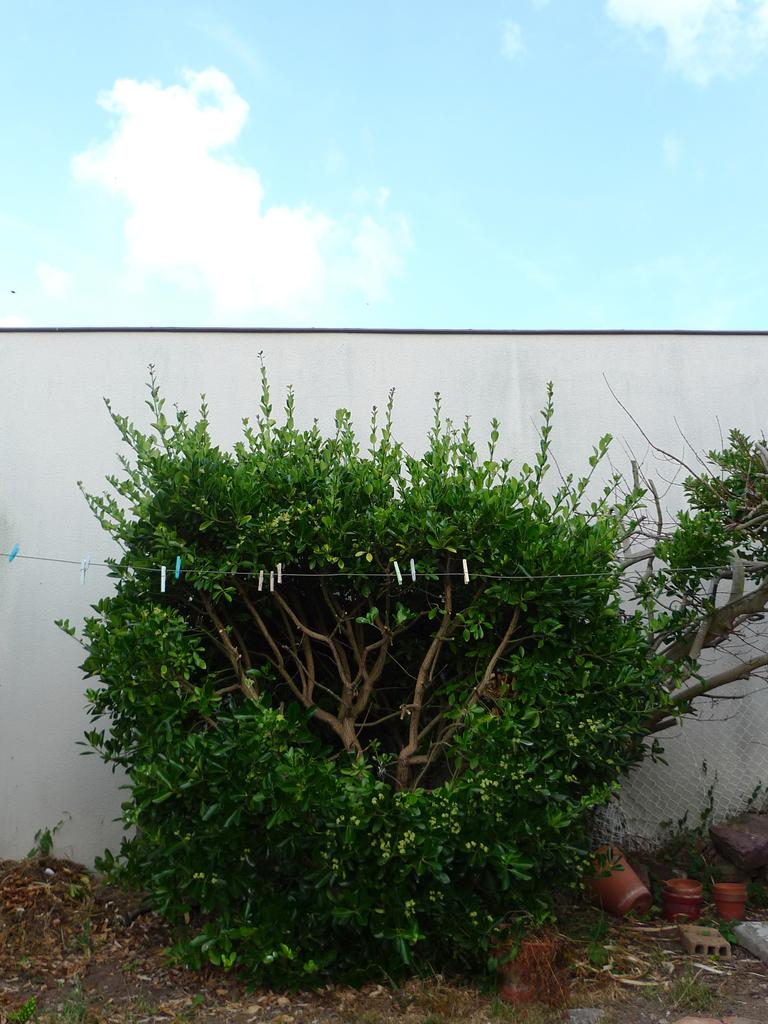What type of plant can be seen in the image? There is a tree in the image. What is attached to the wire in the image? There are clips on a wire in the image. What objects are on the ground in the image? There are flower pots on the ground in the image. What is the background of the image? The sky with clouds is visible in the background of the image. What type of structure is present in the image? There is a wall in the image. How many amusement parks are visible in the image? There are no amusement parks visible in the image. Can you see someone kicking a ball in the image? There is no person kicking a ball in the image. 